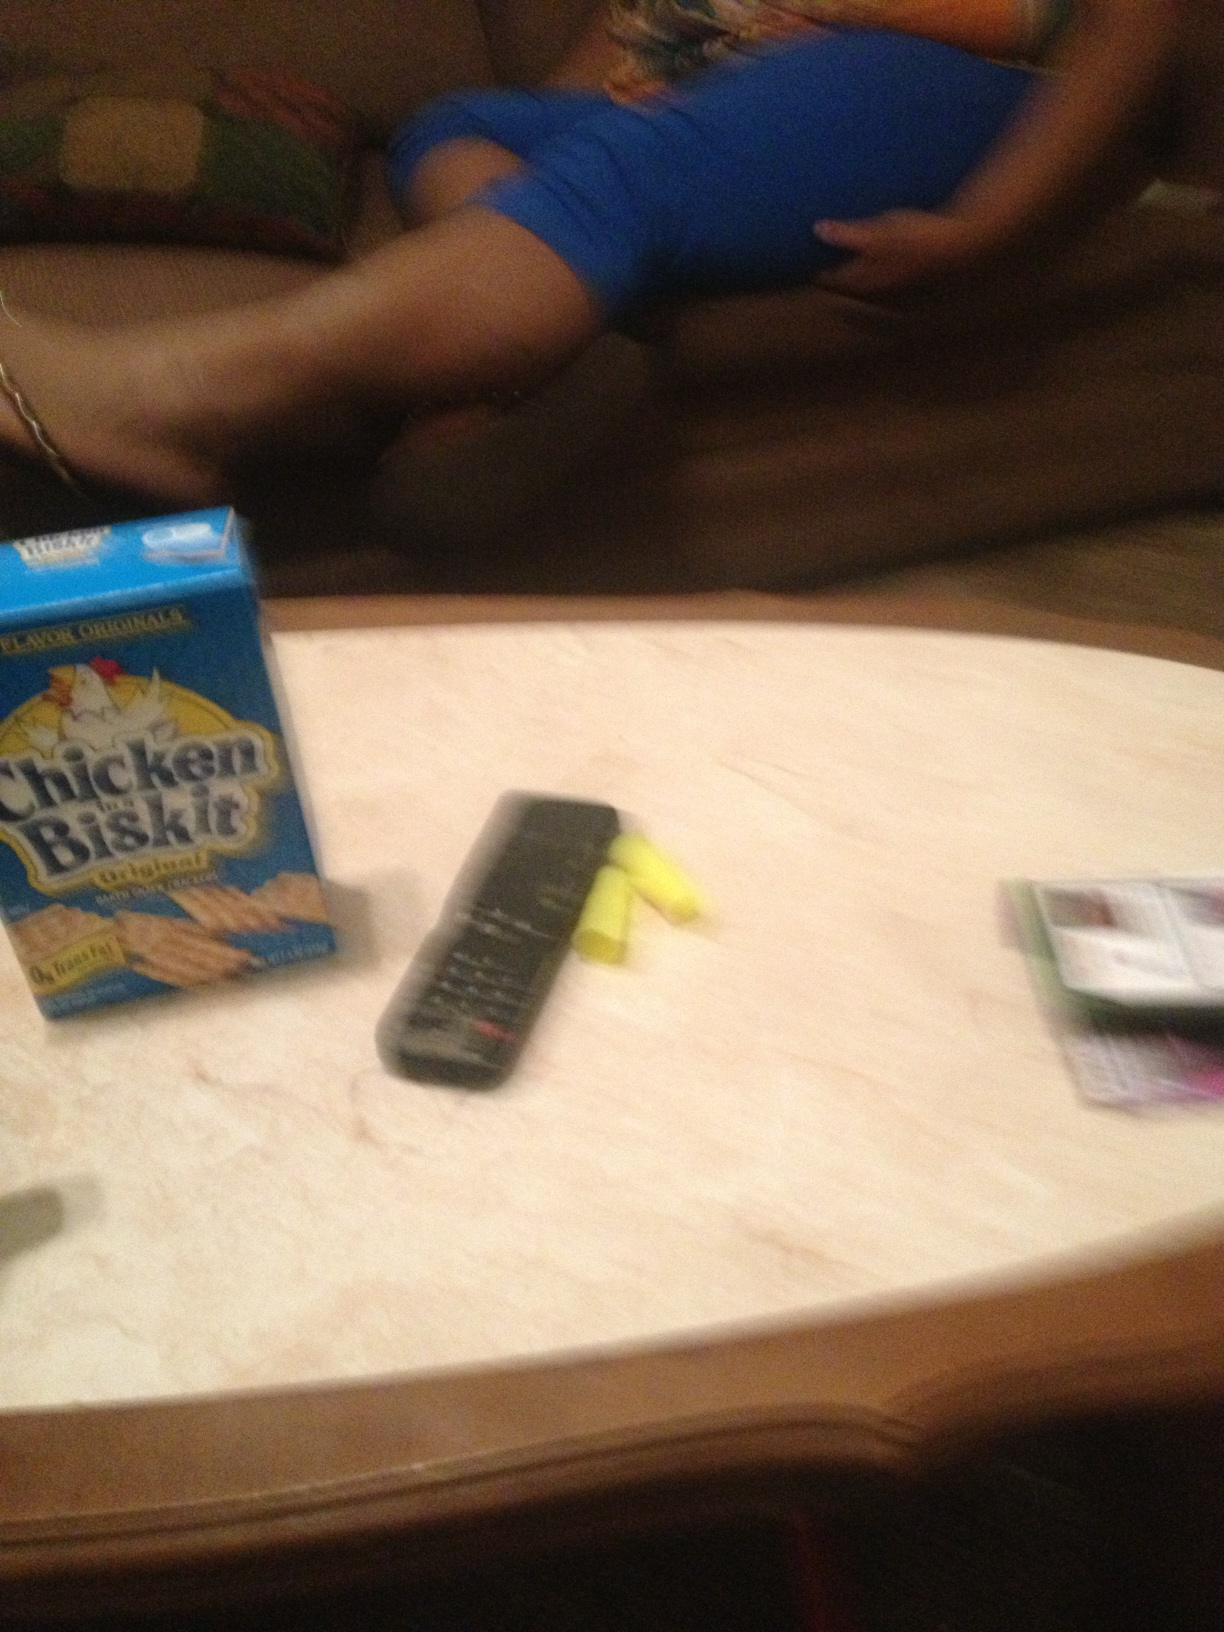What is this person wearing? Due to the low resolution and angle of the image, it is not possible to accurately determine the specifics of what the person is wearing. However, the person appears to be wearing a blue top or shirt. 